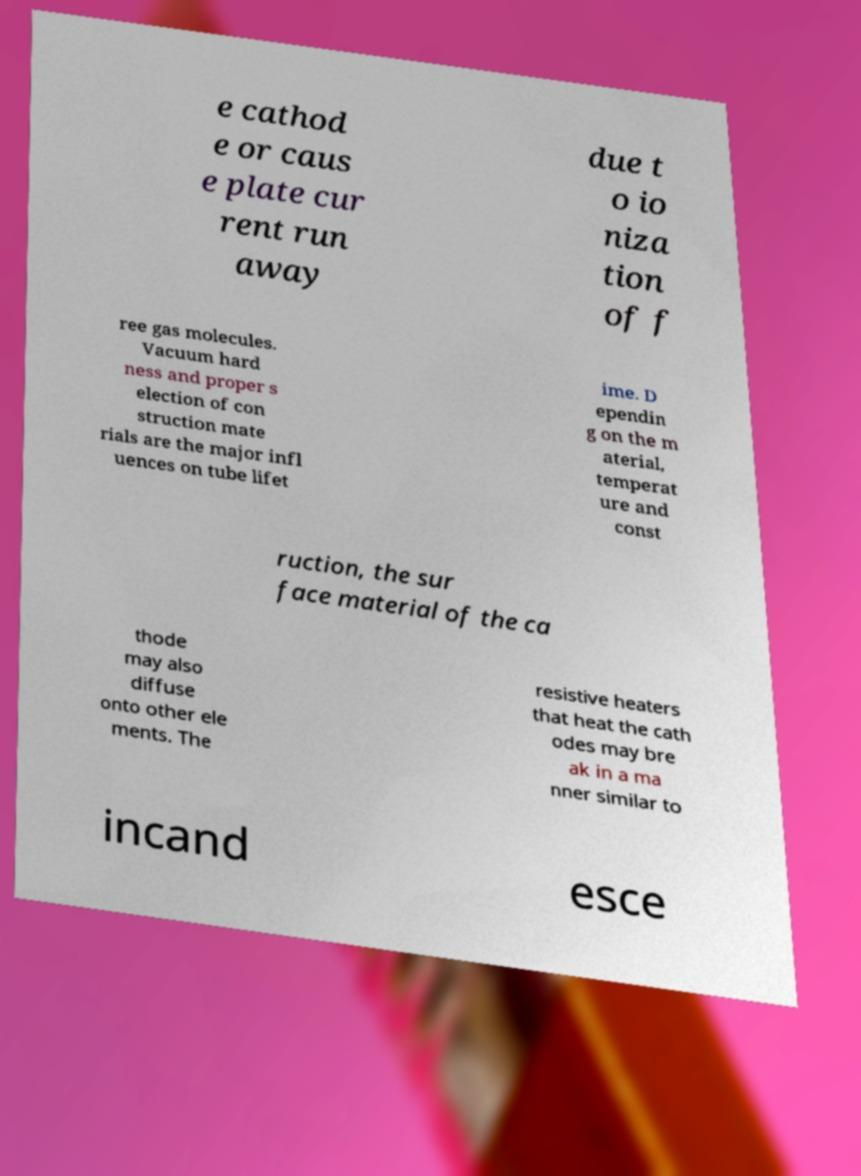What messages or text are displayed in this image? I need them in a readable, typed format. e cathod e or caus e plate cur rent run away due t o io niza tion of f ree gas molecules. Vacuum hard ness and proper s election of con struction mate rials are the major infl uences on tube lifet ime. D ependin g on the m aterial, temperat ure and const ruction, the sur face material of the ca thode may also diffuse onto other ele ments. The resistive heaters that heat the cath odes may bre ak in a ma nner similar to incand esce 